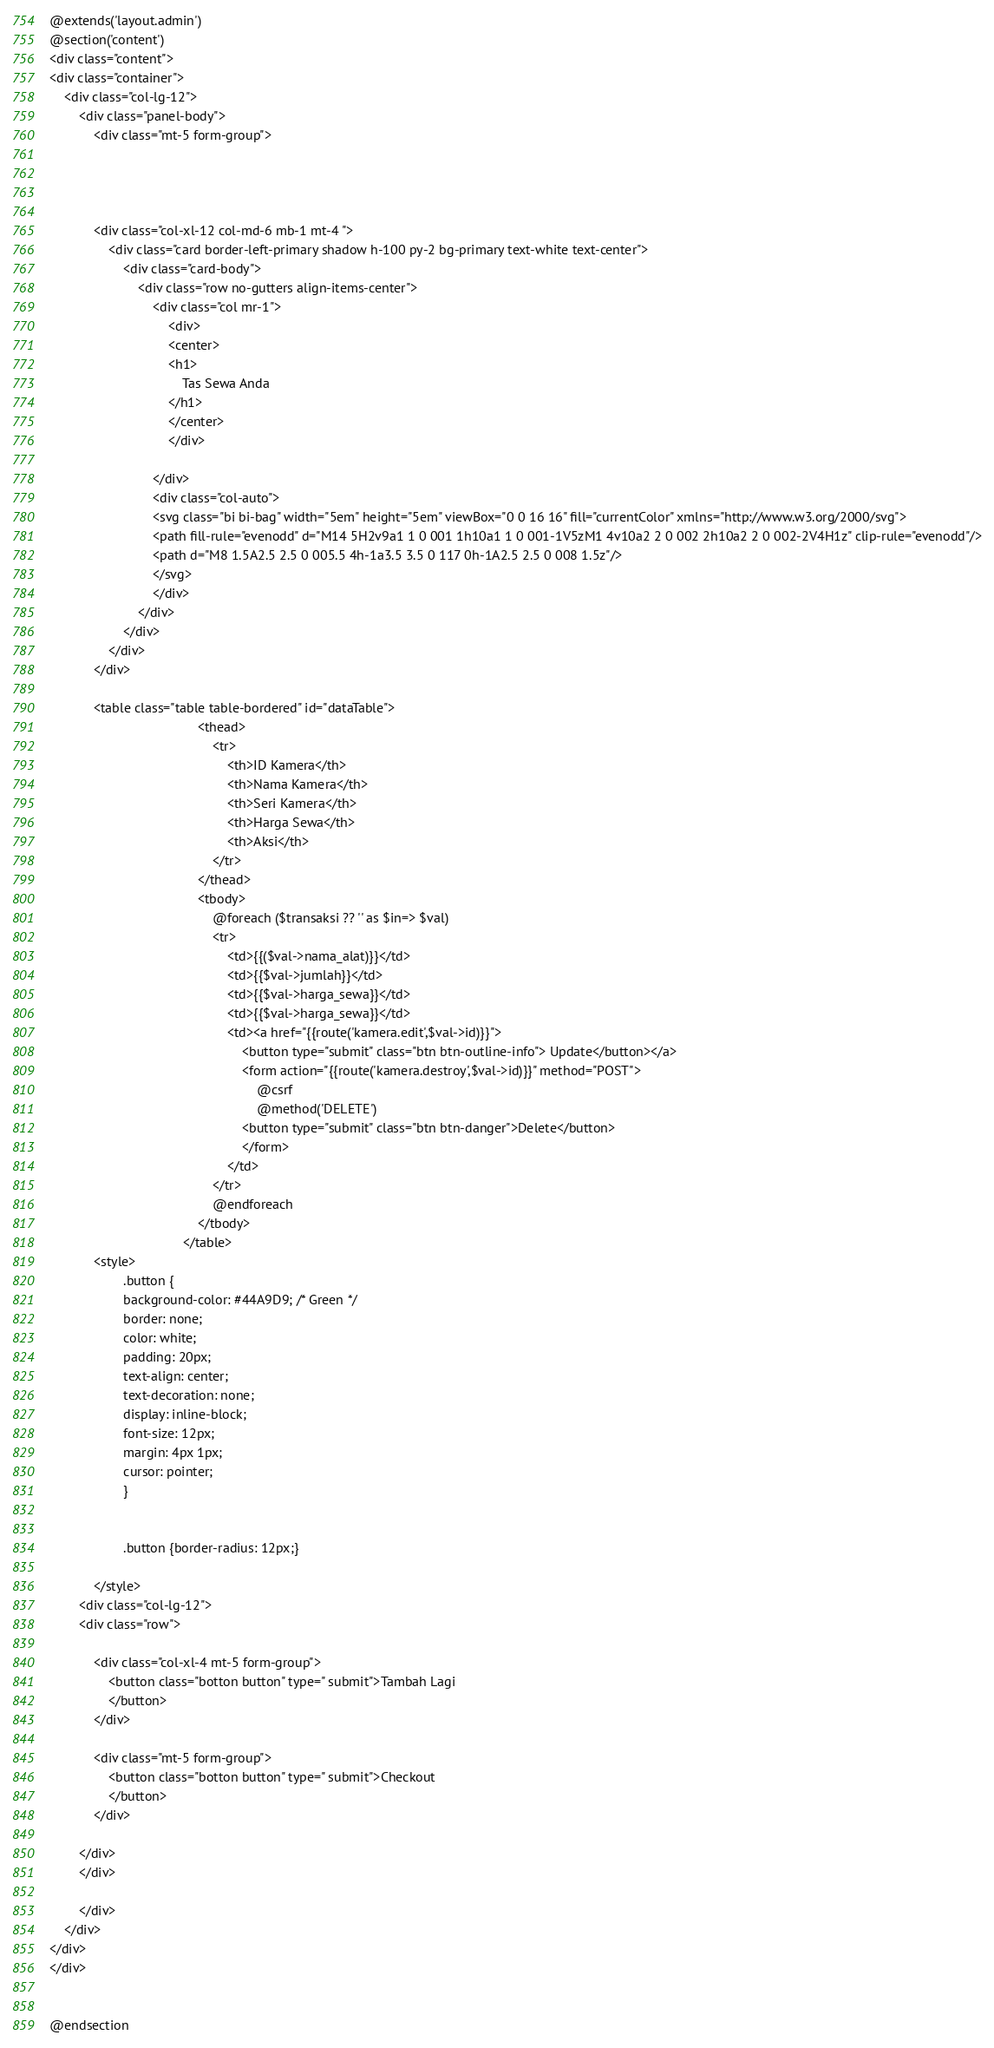Convert code to text. <code><loc_0><loc_0><loc_500><loc_500><_PHP_>@extends('layout.admin')
@section('content')
<div class="content">
<div class="container">
    <div class="col-lg-12">
        <div class="panel-body">
            <div class="mt-5 form-group">
            


     
            <div class="col-xl-12 col-md-6 mb-1 mt-4 ">
                <div class="card border-left-primary shadow h-100 py-2 bg-primary text-white text-center">
                    <div class="card-body">
                        <div class="row no-gutters align-items-center">
                            <div class="col mr-1">
                                <div>
                                <center>
                                <h1>
                                    Tas Sewa Anda
                                </h1>
                                </center>
                                </div>
                               
                            </div>
                            <div class="col-auto">
                            <svg class="bi bi-bag" width="5em" height="5em" viewBox="0 0 16 16" fill="currentColor" xmlns="http://www.w3.org/2000/svg">
                            <path fill-rule="evenodd" d="M14 5H2v9a1 1 0 001 1h10a1 1 0 001-1V5zM1 4v10a2 2 0 002 2h10a2 2 0 002-2V4H1z" clip-rule="evenodd"/>
                            <path d="M8 1.5A2.5 2.5 0 005.5 4h-1a3.5 3.5 0 117 0h-1A2.5 2.5 0 008 1.5z"/>
                            </svg>
                            </div>
                        </div>
                    </div>
                </div>
            </div>

            <table class="table table-bordered" id="dataTable">
                                        <thead>
                                            <tr>
                                                <th>ID Kamera</th>
                                                <th>Nama Kamera</th>
                                                <th>Seri Kamera</th>
                                                <th>Harga Sewa</th>
                                                <th>Aksi</th>
                                            </tr>
                                        </thead>
                                        <tbody>
                                            @foreach ($transaksi ?? '' as $in=> $val)
                                            <tr>
                                                <td>{{($val->nama_alat)}}</td>
                                                <td>{{$val->jumlah}}</td>
                                                <td>{{$val->harga_sewa}}</td>
                                                <td>{{$val->harga_sewa}}</td>
                                                <td><a href="{{route('kamera.edit',$val->id)}}">
                                                    <button type="submit" class="btn btn-outline-info"> Update</button></a>
                                                    <form action="{{route('kamera.destroy',$val->id)}}" method="POST">
                                                        @csrf
                                                        @method('DELETE')
                                                    <button type="submit" class="btn btn-danger">Delete</button>
                                                    </form>
                                                </td>
                                            </tr>
                                            @endforeach
                                        </tbody>
                                    </table>
            <style>
                    .button {
                    background-color: #44A9D9; /* Green */
                    border: none;
                    color: white;
                    padding: 20px;
                    text-align: center;
                    text-decoration: none;
                    display: inline-block;
                    font-size: 12px;
                    margin: 4px 1px;
                    cursor: pointer;
                    }

                    
                    .button {border-radius: 12px;}
                    
            </style>
        <div class="col-lg-12">
        <div class="row">

            <div class="col-xl-4 mt-5 form-group">
                <button class="botton button" type=" submit">Tambah Lagi
                </button>
            </div>

            <div class="mt-5 form-group">
                <button class="botton button" type=" submit">Checkout
                </button>
            </div>

        </div>
        </div>

        </div>
    </div>
</div>
</div>


@endsection

</code> 